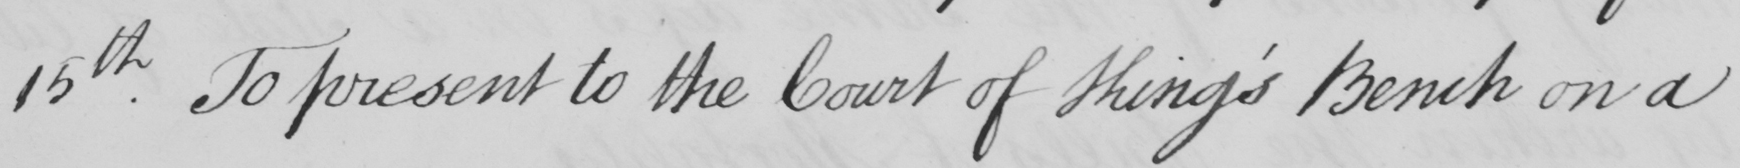Please provide the text content of this handwritten line. 15th . To present to the Court of King ' s Bench on a 